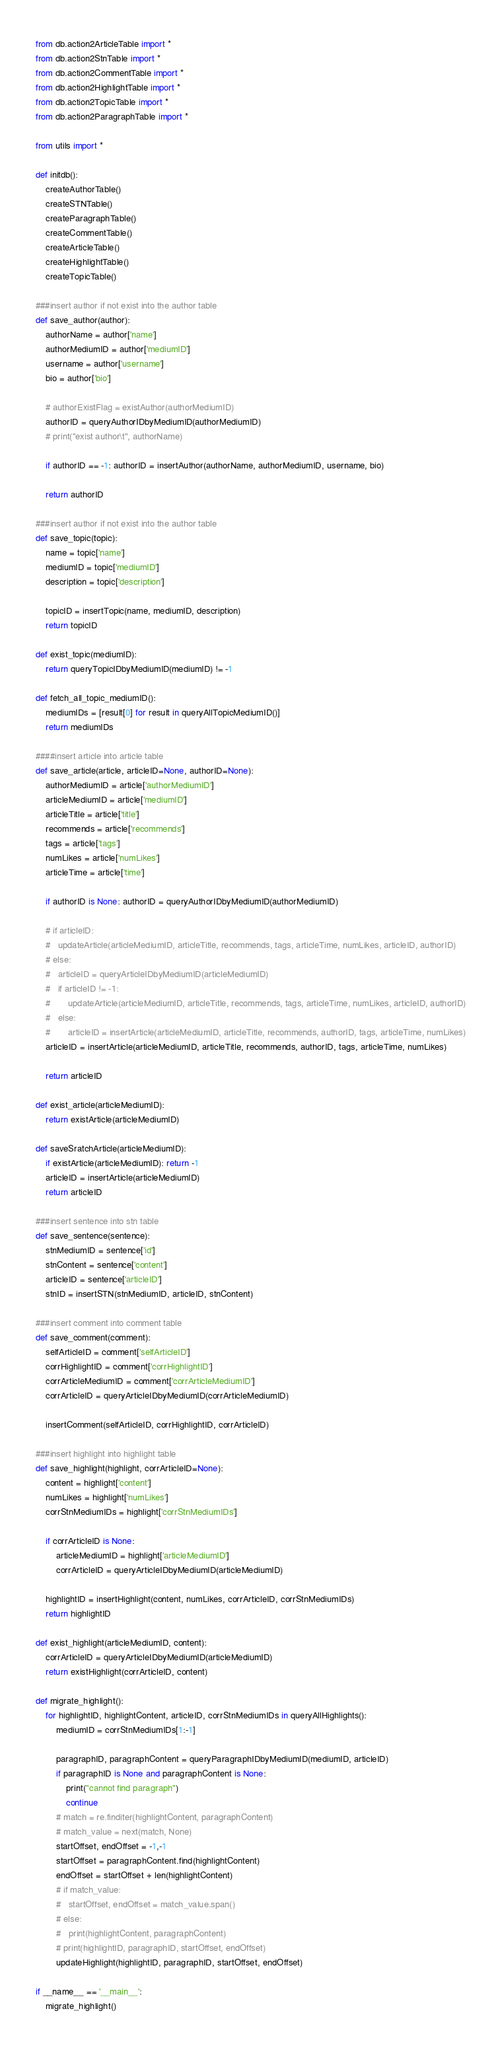Convert code to text. <code><loc_0><loc_0><loc_500><loc_500><_Python_>from db.action2ArticleTable import *
from db.action2StnTable import *
from db.action2CommentTable import *
from db.action2HighlightTable import *
from db.action2TopicTable import *
from db.action2ParagraphTable import *

from utils import *

def initdb():
	createAuthorTable()
	createSTNTable()
	createParagraphTable()
	createCommentTable()
	createArticleTable()
	createHighlightTable()
	createTopicTable()

###insert author if not exist into the author table
def save_author(author):
	authorName = author['name']
	authorMediumID = author['mediumID']
	username = author['username']
	bio = author['bio']

	# authorExistFlag = existAuthor(authorMediumID)
	authorID = queryAuthorIDbyMediumID(authorMediumID)
	# print("exist author\t", authorName)

	if authorID == -1: authorID = insertAuthor(authorName, authorMediumID, username, bio)

	return authorID

###insert author if not exist into the author table
def save_topic(topic):
	name = topic['name']
	mediumID = topic['mediumID']
	description = topic['description']

	topicID = insertTopic(name, mediumID, description)
	return topicID

def exist_topic(mediumID):
	return queryTopicIDbyMediumID(mediumID) != -1

def fetch_all_topic_mediumID():
	mediumIDs = [result[0] for result in queryAllTopicMediumID()]
	return mediumIDs

####insert article into article table
def save_article(article, articleID=None, authorID=None):
	authorMediumID = article['authorMediumID']
	articleMediumID = article['mediumID']
	articleTitle = article['title']
	recommends = article['recommends']
	tags = article['tags']
	numLikes = article['numLikes']
	articleTime = article['time']

	if authorID is None: authorID = queryAuthorIDbyMediumID(authorMediumID)

	# if articleID:
	# 	updateArticle(articleMediumID, articleTitle, recommends, tags, articleTime, numLikes, articleID, authorID)
	# else:
	# 	articleID = queryArticleIDbyMediumID(articleMediumID)
	# 	if articleID != -1:
	# 		updateArticle(articleMediumID, articleTitle, recommends, tags, articleTime, numLikes, articleID, authorID)
	# 	else:
	# 		articleID = insertArticle(articleMediumID, articleTitle, recommends, authorID, tags, articleTime, numLikes)
	articleID = insertArticle(articleMediumID, articleTitle, recommends, authorID, tags, articleTime, numLikes)

	return articleID

def exist_article(articleMediumID):
	return existArticle(articleMediumID)

def saveSratchArticle(articleMediumID):
	if existArticle(articleMediumID): return -1
	articleID = insertArticle(articleMediumID)
	return articleID

###insert sentence into stn table
def save_sentence(sentence):
	stnMediumID = sentence['id']
	stnContent = sentence['content']
	articleID = sentence['articleID']
	stnID = insertSTN(stnMediumID, articleID, stnContent)

###insert comment into comment table
def save_comment(comment):
	selfArticleID = comment['selfArticleID']
	corrHighlightID = comment['corrHighlightID']
	corrArticleMediumID = comment['corrArticleMediumID']
	corrArticleID = queryArticleIDbyMediumID(corrArticleMediumID)

	insertComment(selfArticleID, corrHighlightID, corrArticleID)

###insert highlight into highlight table
def save_highlight(highlight, corrArticleID=None):
	content = highlight['content']
	numLikes = highlight['numLikes']
	corrStnMediumIDs = highlight['corrStnMediumIDs']

	if corrArticleID is None:
		articleMediumID = highlight['articleMediumID']
		corrArticleID = queryArticleIDbyMediumID(articleMediumID)

	highlightID = insertHighlight(content, numLikes, corrArticleID, corrStnMediumIDs)
	return highlightID

def exist_highlight(articleMediumID, content):
	corrArticleID = queryArticleIDbyMediumID(articleMediumID)
	return existHighlight(corrArticleID, content)

def migrate_highlight():
	for highlightID, highlightContent, articleID, corrStnMediumIDs in queryAllHighlights():
		mediumID = corrStnMediumIDs[1:-1]

		paragraphID, paragraphContent = queryParagraphIDbyMediumID(mediumID, articleID)
		if paragraphID is None and paragraphContent is None:
			print("cannot find paragraph")
			continue
		# match = re.finditer(highlightContent, paragraphContent)
		# match_value = next(match, None)
		startOffset, endOffset = -1,-1
		startOffset = paragraphContent.find(highlightContent)
		endOffset = startOffset + len(highlightContent)
		# if match_value:
		# 	startOffset, endOffset = match_value.span()
		# else:
		# 	print(highlightContent, paragraphContent)
		# print(highlightID, paragraphID, startOffset, endOffset)
		updateHighlight(highlightID, paragraphID, startOffset, endOffset)

if __name__ == '__main__':
	migrate_highlight()
</code> 